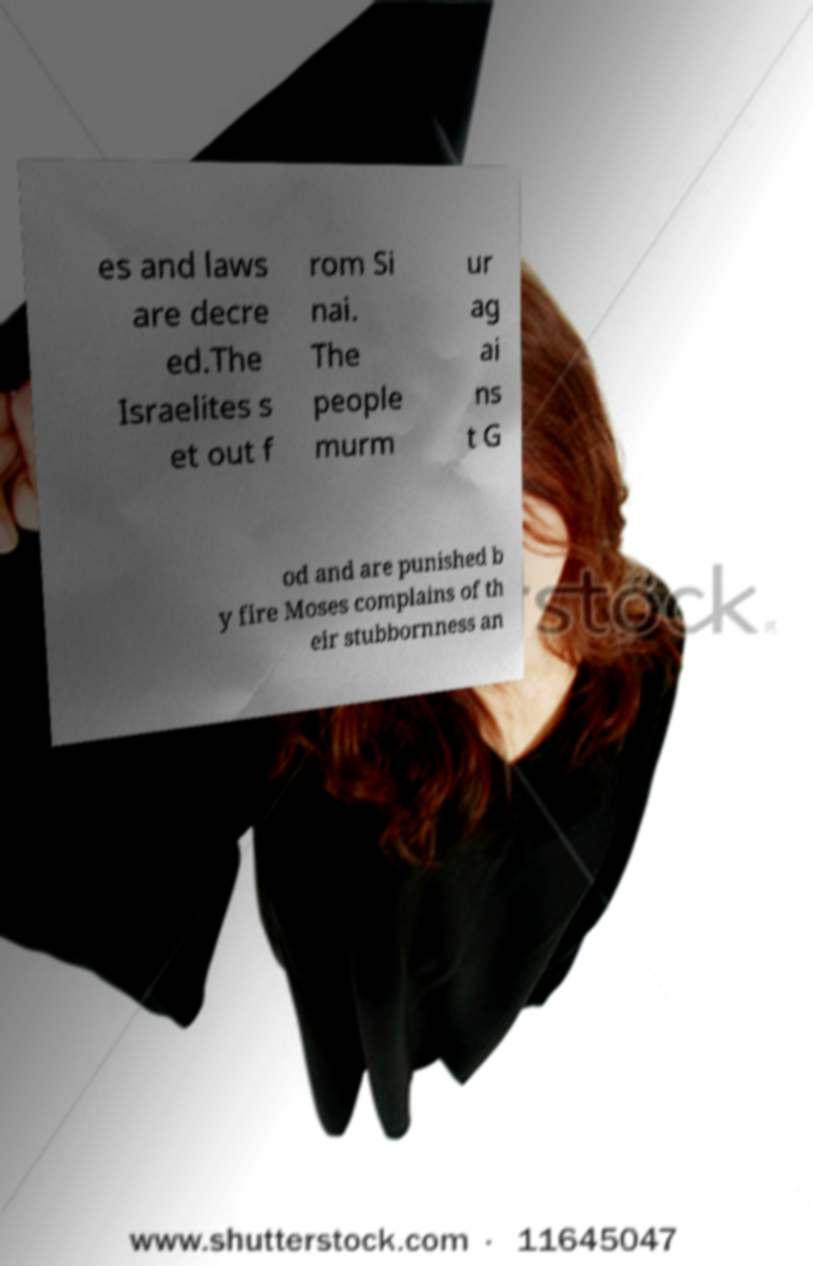There's text embedded in this image that I need extracted. Can you transcribe it verbatim? es and laws are decre ed.The Israelites s et out f rom Si nai. The people murm ur ag ai ns t G od and are punished b y fire Moses complains of th eir stubbornness an 